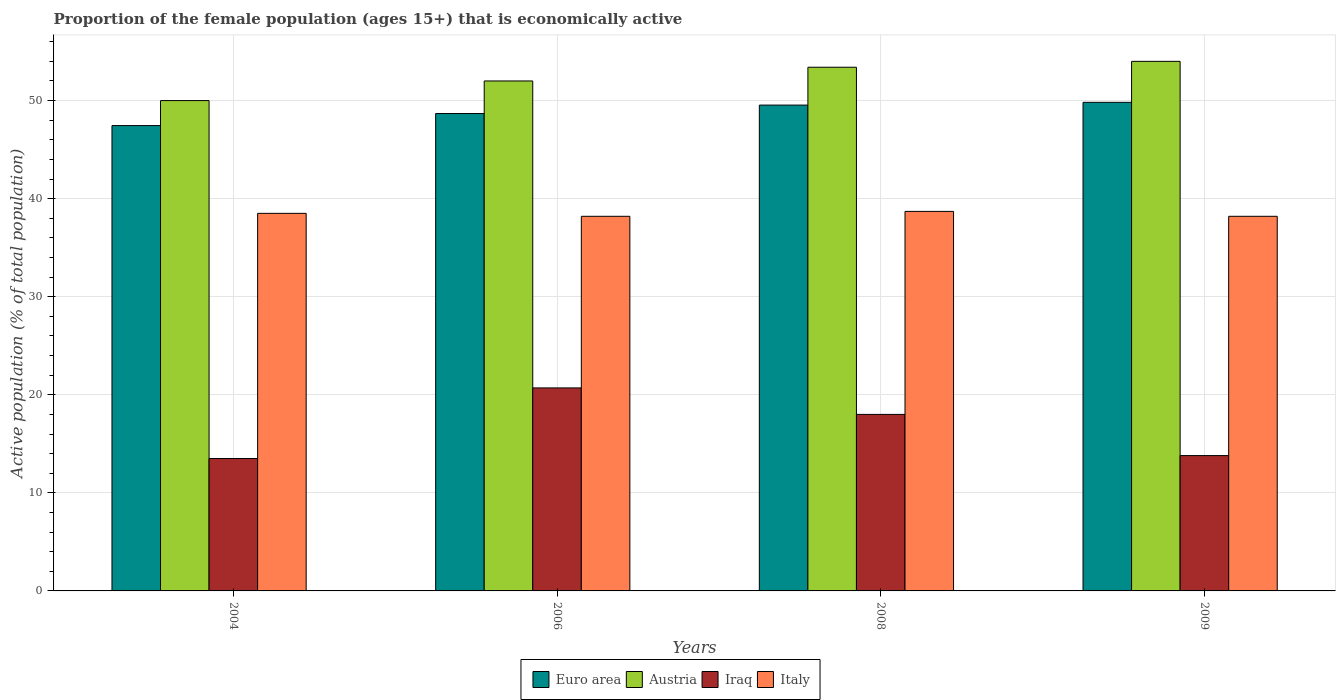Are the number of bars per tick equal to the number of legend labels?
Provide a short and direct response. Yes. Are the number of bars on each tick of the X-axis equal?
Offer a terse response. Yes. How many bars are there on the 3rd tick from the left?
Offer a very short reply. 4. In how many cases, is the number of bars for a given year not equal to the number of legend labels?
Ensure brevity in your answer.  0. What is the proportion of the female population that is economically active in Austria in 2008?
Offer a terse response. 53.4. Across all years, what is the maximum proportion of the female population that is economically active in Euro area?
Ensure brevity in your answer.  49.82. Across all years, what is the minimum proportion of the female population that is economically active in Iraq?
Give a very brief answer. 13.5. In which year was the proportion of the female population that is economically active in Italy maximum?
Your response must be concise. 2008. In which year was the proportion of the female population that is economically active in Italy minimum?
Offer a very short reply. 2006. What is the total proportion of the female population that is economically active in Iraq in the graph?
Ensure brevity in your answer.  66. What is the difference between the proportion of the female population that is economically active in Austria in 2006 and that in 2009?
Make the answer very short. -2. What is the difference between the proportion of the female population that is economically active in Euro area in 2009 and the proportion of the female population that is economically active in Italy in 2006?
Provide a succinct answer. 11.62. What is the average proportion of the female population that is economically active in Austria per year?
Offer a very short reply. 52.35. In the year 2004, what is the difference between the proportion of the female population that is economically active in Euro area and proportion of the female population that is economically active in Iraq?
Keep it short and to the point. 33.95. In how many years, is the proportion of the female population that is economically active in Austria greater than 22 %?
Your answer should be compact. 4. What is the ratio of the proportion of the female population that is economically active in Italy in 2004 to that in 2008?
Offer a very short reply. 0.99. What is the difference between the highest and the second highest proportion of the female population that is economically active in Austria?
Your response must be concise. 0.6. What is the difference between the highest and the lowest proportion of the female population that is economically active in Euro area?
Offer a terse response. 2.37. In how many years, is the proportion of the female population that is economically active in Iraq greater than the average proportion of the female population that is economically active in Iraq taken over all years?
Your response must be concise. 2. Is the sum of the proportion of the female population that is economically active in Iraq in 2004 and 2009 greater than the maximum proportion of the female population that is economically active in Euro area across all years?
Keep it short and to the point. No. Is it the case that in every year, the sum of the proportion of the female population that is economically active in Italy and proportion of the female population that is economically active in Austria is greater than the sum of proportion of the female population that is economically active in Iraq and proportion of the female population that is economically active in Euro area?
Make the answer very short. Yes. What does the 4th bar from the left in 2009 represents?
Your response must be concise. Italy. What does the 3rd bar from the right in 2008 represents?
Offer a very short reply. Austria. How many bars are there?
Keep it short and to the point. 16. How many years are there in the graph?
Your answer should be compact. 4. Where does the legend appear in the graph?
Your response must be concise. Bottom center. How many legend labels are there?
Offer a very short reply. 4. What is the title of the graph?
Ensure brevity in your answer.  Proportion of the female population (ages 15+) that is economically active. Does "Yemen, Rep." appear as one of the legend labels in the graph?
Offer a terse response. No. What is the label or title of the Y-axis?
Keep it short and to the point. Active population (% of total population). What is the Active population (% of total population) of Euro area in 2004?
Provide a short and direct response. 47.45. What is the Active population (% of total population) in Austria in 2004?
Offer a very short reply. 50. What is the Active population (% of total population) of Italy in 2004?
Your answer should be compact. 38.5. What is the Active population (% of total population) of Euro area in 2006?
Provide a short and direct response. 48.68. What is the Active population (% of total population) in Iraq in 2006?
Your answer should be compact. 20.7. What is the Active population (% of total population) in Italy in 2006?
Your answer should be very brief. 38.2. What is the Active population (% of total population) in Euro area in 2008?
Make the answer very short. 49.54. What is the Active population (% of total population) of Austria in 2008?
Your answer should be compact. 53.4. What is the Active population (% of total population) in Italy in 2008?
Ensure brevity in your answer.  38.7. What is the Active population (% of total population) in Euro area in 2009?
Give a very brief answer. 49.82. What is the Active population (% of total population) of Austria in 2009?
Your answer should be very brief. 54. What is the Active population (% of total population) in Iraq in 2009?
Give a very brief answer. 13.8. What is the Active population (% of total population) of Italy in 2009?
Ensure brevity in your answer.  38.2. Across all years, what is the maximum Active population (% of total population) of Euro area?
Keep it short and to the point. 49.82. Across all years, what is the maximum Active population (% of total population) in Austria?
Keep it short and to the point. 54. Across all years, what is the maximum Active population (% of total population) in Iraq?
Keep it short and to the point. 20.7. Across all years, what is the maximum Active population (% of total population) in Italy?
Your response must be concise. 38.7. Across all years, what is the minimum Active population (% of total population) of Euro area?
Give a very brief answer. 47.45. Across all years, what is the minimum Active population (% of total population) of Austria?
Your response must be concise. 50. Across all years, what is the minimum Active population (% of total population) in Italy?
Make the answer very short. 38.2. What is the total Active population (% of total population) in Euro area in the graph?
Offer a terse response. 195.49. What is the total Active population (% of total population) of Austria in the graph?
Ensure brevity in your answer.  209.4. What is the total Active population (% of total population) of Iraq in the graph?
Provide a short and direct response. 66. What is the total Active population (% of total population) in Italy in the graph?
Your answer should be compact. 153.6. What is the difference between the Active population (% of total population) of Euro area in 2004 and that in 2006?
Your answer should be compact. -1.23. What is the difference between the Active population (% of total population) of Austria in 2004 and that in 2006?
Your response must be concise. -2. What is the difference between the Active population (% of total population) in Iraq in 2004 and that in 2006?
Your answer should be very brief. -7.2. What is the difference between the Active population (% of total population) of Italy in 2004 and that in 2006?
Provide a succinct answer. 0.3. What is the difference between the Active population (% of total population) in Euro area in 2004 and that in 2008?
Your answer should be compact. -2.09. What is the difference between the Active population (% of total population) in Euro area in 2004 and that in 2009?
Your answer should be compact. -2.37. What is the difference between the Active population (% of total population) in Austria in 2004 and that in 2009?
Your answer should be compact. -4. What is the difference between the Active population (% of total population) in Iraq in 2004 and that in 2009?
Your answer should be very brief. -0.3. What is the difference between the Active population (% of total population) of Euro area in 2006 and that in 2008?
Offer a terse response. -0.86. What is the difference between the Active population (% of total population) in Iraq in 2006 and that in 2008?
Keep it short and to the point. 2.7. What is the difference between the Active population (% of total population) of Italy in 2006 and that in 2008?
Offer a very short reply. -0.5. What is the difference between the Active population (% of total population) of Euro area in 2006 and that in 2009?
Offer a terse response. -1.14. What is the difference between the Active population (% of total population) of Austria in 2006 and that in 2009?
Keep it short and to the point. -2. What is the difference between the Active population (% of total population) in Italy in 2006 and that in 2009?
Give a very brief answer. 0. What is the difference between the Active population (% of total population) in Euro area in 2008 and that in 2009?
Offer a very short reply. -0.28. What is the difference between the Active population (% of total population) in Euro area in 2004 and the Active population (% of total population) in Austria in 2006?
Keep it short and to the point. -4.55. What is the difference between the Active population (% of total population) in Euro area in 2004 and the Active population (% of total population) in Iraq in 2006?
Keep it short and to the point. 26.75. What is the difference between the Active population (% of total population) in Euro area in 2004 and the Active population (% of total population) in Italy in 2006?
Your answer should be compact. 9.25. What is the difference between the Active population (% of total population) in Austria in 2004 and the Active population (% of total population) in Iraq in 2006?
Make the answer very short. 29.3. What is the difference between the Active population (% of total population) in Iraq in 2004 and the Active population (% of total population) in Italy in 2006?
Ensure brevity in your answer.  -24.7. What is the difference between the Active population (% of total population) in Euro area in 2004 and the Active population (% of total population) in Austria in 2008?
Your answer should be compact. -5.95. What is the difference between the Active population (% of total population) in Euro area in 2004 and the Active population (% of total population) in Iraq in 2008?
Keep it short and to the point. 29.45. What is the difference between the Active population (% of total population) of Euro area in 2004 and the Active population (% of total population) of Italy in 2008?
Provide a short and direct response. 8.75. What is the difference between the Active population (% of total population) of Austria in 2004 and the Active population (% of total population) of Iraq in 2008?
Provide a succinct answer. 32. What is the difference between the Active population (% of total population) of Austria in 2004 and the Active population (% of total population) of Italy in 2008?
Make the answer very short. 11.3. What is the difference between the Active population (% of total population) of Iraq in 2004 and the Active population (% of total population) of Italy in 2008?
Make the answer very short. -25.2. What is the difference between the Active population (% of total population) of Euro area in 2004 and the Active population (% of total population) of Austria in 2009?
Give a very brief answer. -6.55. What is the difference between the Active population (% of total population) in Euro area in 2004 and the Active population (% of total population) in Iraq in 2009?
Provide a succinct answer. 33.65. What is the difference between the Active population (% of total population) in Euro area in 2004 and the Active population (% of total population) in Italy in 2009?
Keep it short and to the point. 9.25. What is the difference between the Active population (% of total population) of Austria in 2004 and the Active population (% of total population) of Iraq in 2009?
Your answer should be very brief. 36.2. What is the difference between the Active population (% of total population) in Iraq in 2004 and the Active population (% of total population) in Italy in 2009?
Keep it short and to the point. -24.7. What is the difference between the Active population (% of total population) of Euro area in 2006 and the Active population (% of total population) of Austria in 2008?
Make the answer very short. -4.72. What is the difference between the Active population (% of total population) of Euro area in 2006 and the Active population (% of total population) of Iraq in 2008?
Provide a short and direct response. 30.68. What is the difference between the Active population (% of total population) of Euro area in 2006 and the Active population (% of total population) of Italy in 2008?
Ensure brevity in your answer.  9.98. What is the difference between the Active population (% of total population) in Austria in 2006 and the Active population (% of total population) in Iraq in 2008?
Give a very brief answer. 34. What is the difference between the Active population (% of total population) of Euro area in 2006 and the Active population (% of total population) of Austria in 2009?
Offer a very short reply. -5.32. What is the difference between the Active population (% of total population) in Euro area in 2006 and the Active population (% of total population) in Iraq in 2009?
Offer a very short reply. 34.88. What is the difference between the Active population (% of total population) of Euro area in 2006 and the Active population (% of total population) of Italy in 2009?
Ensure brevity in your answer.  10.48. What is the difference between the Active population (% of total population) of Austria in 2006 and the Active population (% of total population) of Iraq in 2009?
Your answer should be compact. 38.2. What is the difference between the Active population (% of total population) in Austria in 2006 and the Active population (% of total population) in Italy in 2009?
Ensure brevity in your answer.  13.8. What is the difference between the Active population (% of total population) in Iraq in 2006 and the Active population (% of total population) in Italy in 2009?
Your answer should be compact. -17.5. What is the difference between the Active population (% of total population) of Euro area in 2008 and the Active population (% of total population) of Austria in 2009?
Provide a succinct answer. -4.46. What is the difference between the Active population (% of total population) in Euro area in 2008 and the Active population (% of total population) in Iraq in 2009?
Your answer should be compact. 35.74. What is the difference between the Active population (% of total population) in Euro area in 2008 and the Active population (% of total population) in Italy in 2009?
Provide a short and direct response. 11.34. What is the difference between the Active population (% of total population) in Austria in 2008 and the Active population (% of total population) in Iraq in 2009?
Your answer should be very brief. 39.6. What is the difference between the Active population (% of total population) of Iraq in 2008 and the Active population (% of total population) of Italy in 2009?
Your answer should be very brief. -20.2. What is the average Active population (% of total population) in Euro area per year?
Ensure brevity in your answer.  48.87. What is the average Active population (% of total population) of Austria per year?
Your answer should be very brief. 52.35. What is the average Active population (% of total population) of Iraq per year?
Keep it short and to the point. 16.5. What is the average Active population (% of total population) in Italy per year?
Ensure brevity in your answer.  38.4. In the year 2004, what is the difference between the Active population (% of total population) of Euro area and Active population (% of total population) of Austria?
Offer a terse response. -2.55. In the year 2004, what is the difference between the Active population (% of total population) in Euro area and Active population (% of total population) in Iraq?
Keep it short and to the point. 33.95. In the year 2004, what is the difference between the Active population (% of total population) in Euro area and Active population (% of total population) in Italy?
Offer a terse response. 8.95. In the year 2004, what is the difference between the Active population (% of total population) of Austria and Active population (% of total population) of Iraq?
Make the answer very short. 36.5. In the year 2006, what is the difference between the Active population (% of total population) in Euro area and Active population (% of total population) in Austria?
Provide a short and direct response. -3.32. In the year 2006, what is the difference between the Active population (% of total population) in Euro area and Active population (% of total population) in Iraq?
Your answer should be compact. 27.98. In the year 2006, what is the difference between the Active population (% of total population) in Euro area and Active population (% of total population) in Italy?
Offer a very short reply. 10.48. In the year 2006, what is the difference between the Active population (% of total population) in Austria and Active population (% of total population) in Iraq?
Offer a terse response. 31.3. In the year 2006, what is the difference between the Active population (% of total population) of Iraq and Active population (% of total population) of Italy?
Offer a terse response. -17.5. In the year 2008, what is the difference between the Active population (% of total population) of Euro area and Active population (% of total population) of Austria?
Provide a succinct answer. -3.86. In the year 2008, what is the difference between the Active population (% of total population) in Euro area and Active population (% of total population) in Iraq?
Provide a short and direct response. 31.54. In the year 2008, what is the difference between the Active population (% of total population) of Euro area and Active population (% of total population) of Italy?
Offer a very short reply. 10.84. In the year 2008, what is the difference between the Active population (% of total population) of Austria and Active population (% of total population) of Iraq?
Provide a short and direct response. 35.4. In the year 2008, what is the difference between the Active population (% of total population) of Iraq and Active population (% of total population) of Italy?
Your answer should be very brief. -20.7. In the year 2009, what is the difference between the Active population (% of total population) in Euro area and Active population (% of total population) in Austria?
Keep it short and to the point. -4.18. In the year 2009, what is the difference between the Active population (% of total population) of Euro area and Active population (% of total population) of Iraq?
Make the answer very short. 36.02. In the year 2009, what is the difference between the Active population (% of total population) of Euro area and Active population (% of total population) of Italy?
Your answer should be compact. 11.62. In the year 2009, what is the difference between the Active population (% of total population) of Austria and Active population (% of total population) of Iraq?
Your answer should be compact. 40.2. In the year 2009, what is the difference between the Active population (% of total population) in Austria and Active population (% of total population) in Italy?
Give a very brief answer. 15.8. In the year 2009, what is the difference between the Active population (% of total population) in Iraq and Active population (% of total population) in Italy?
Keep it short and to the point. -24.4. What is the ratio of the Active population (% of total population) of Euro area in 2004 to that in 2006?
Provide a short and direct response. 0.97. What is the ratio of the Active population (% of total population) of Austria in 2004 to that in 2006?
Keep it short and to the point. 0.96. What is the ratio of the Active population (% of total population) of Iraq in 2004 to that in 2006?
Ensure brevity in your answer.  0.65. What is the ratio of the Active population (% of total population) of Italy in 2004 to that in 2006?
Offer a terse response. 1.01. What is the ratio of the Active population (% of total population) in Euro area in 2004 to that in 2008?
Keep it short and to the point. 0.96. What is the ratio of the Active population (% of total population) in Austria in 2004 to that in 2008?
Keep it short and to the point. 0.94. What is the ratio of the Active population (% of total population) in Euro area in 2004 to that in 2009?
Offer a terse response. 0.95. What is the ratio of the Active population (% of total population) in Austria in 2004 to that in 2009?
Ensure brevity in your answer.  0.93. What is the ratio of the Active population (% of total population) of Iraq in 2004 to that in 2009?
Ensure brevity in your answer.  0.98. What is the ratio of the Active population (% of total population) in Italy in 2004 to that in 2009?
Your answer should be compact. 1.01. What is the ratio of the Active population (% of total population) in Euro area in 2006 to that in 2008?
Offer a terse response. 0.98. What is the ratio of the Active population (% of total population) of Austria in 2006 to that in 2008?
Keep it short and to the point. 0.97. What is the ratio of the Active population (% of total population) of Iraq in 2006 to that in 2008?
Provide a succinct answer. 1.15. What is the ratio of the Active population (% of total population) in Italy in 2006 to that in 2008?
Provide a succinct answer. 0.99. What is the ratio of the Active population (% of total population) in Euro area in 2006 to that in 2009?
Provide a short and direct response. 0.98. What is the ratio of the Active population (% of total population) in Italy in 2006 to that in 2009?
Offer a terse response. 1. What is the ratio of the Active population (% of total population) of Austria in 2008 to that in 2009?
Your response must be concise. 0.99. What is the ratio of the Active population (% of total population) of Iraq in 2008 to that in 2009?
Keep it short and to the point. 1.3. What is the ratio of the Active population (% of total population) of Italy in 2008 to that in 2009?
Offer a terse response. 1.01. What is the difference between the highest and the second highest Active population (% of total population) of Euro area?
Your response must be concise. 0.28. What is the difference between the highest and the second highest Active population (% of total population) of Iraq?
Offer a terse response. 2.7. What is the difference between the highest and the lowest Active population (% of total population) of Euro area?
Your response must be concise. 2.37. What is the difference between the highest and the lowest Active population (% of total population) of Austria?
Offer a very short reply. 4. What is the difference between the highest and the lowest Active population (% of total population) in Iraq?
Your response must be concise. 7.2. 